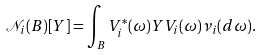<formula> <loc_0><loc_0><loc_500><loc_500>\mathcal { N } _ { i } ( B ) [ Y ] = \int _ { B } V _ { i } ^ { \ast } ( \omega ) Y V _ { i } ( \omega ) \nu _ { i } ( d \omega ) .</formula> 